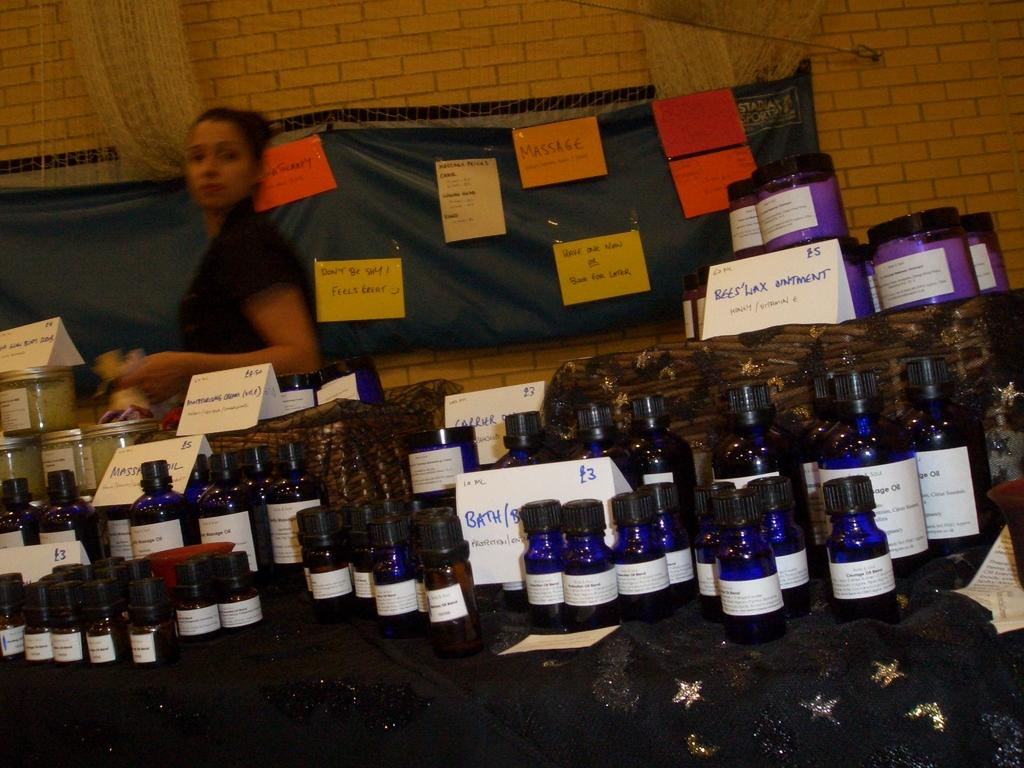<image>
Create a compact narrative representing the image presented. A varying collection of ointments and bath oils at a sale. 